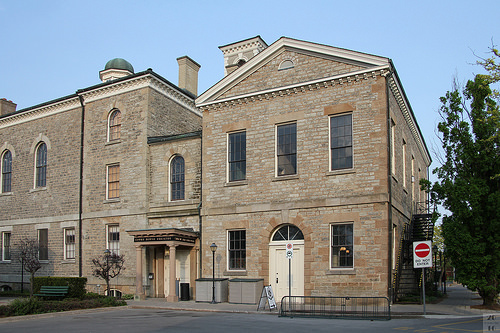<image>
Is the sign to the left of the window? No. The sign is not to the left of the window. From this viewpoint, they have a different horizontal relationship. 